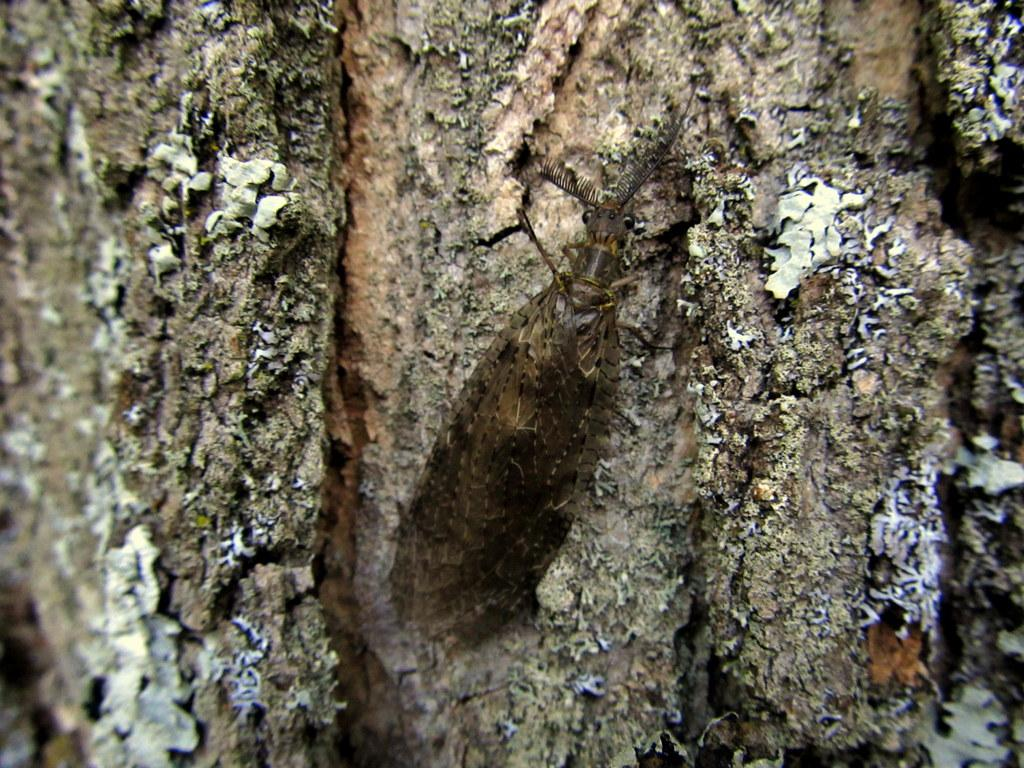What is present in the image? There is an insect in the image. Where is the insect located? The insect is on the trunk of a tree. How does the insect kick the ball in the image? There is no ball present in the image, and insects do not have the ability to kick. 